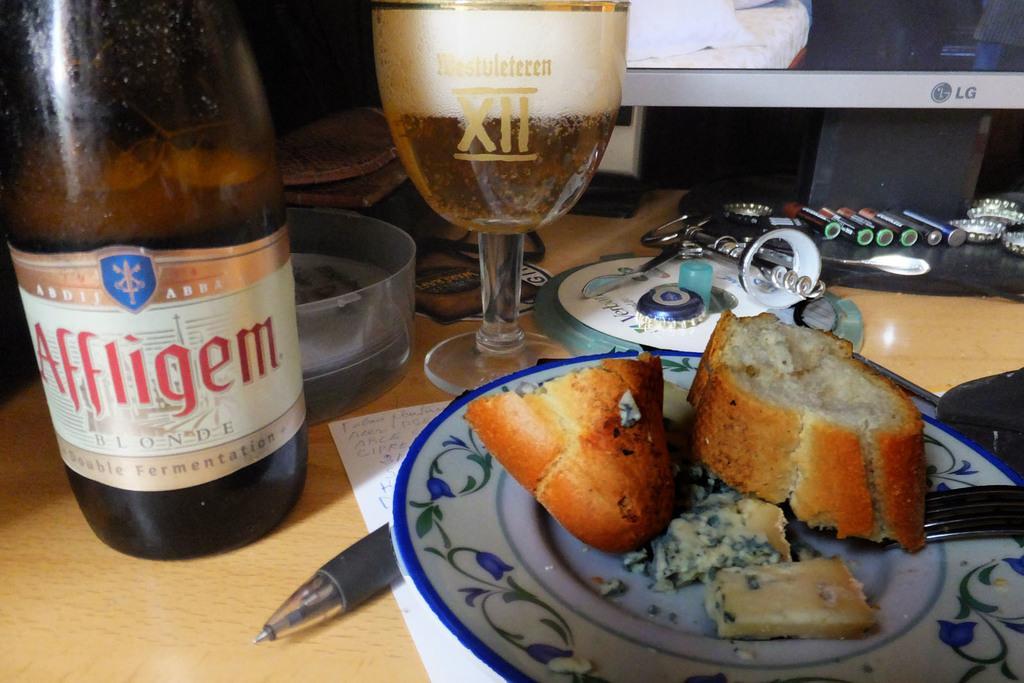Can you describe this image briefly? In this image there is a table. On the table there is a bottle, a wine glass, ashtray, plate with food in it, fork, pen, paper, bottle caps, markers and monitor. On the bottle there is a label with text "Affligem" on it. 